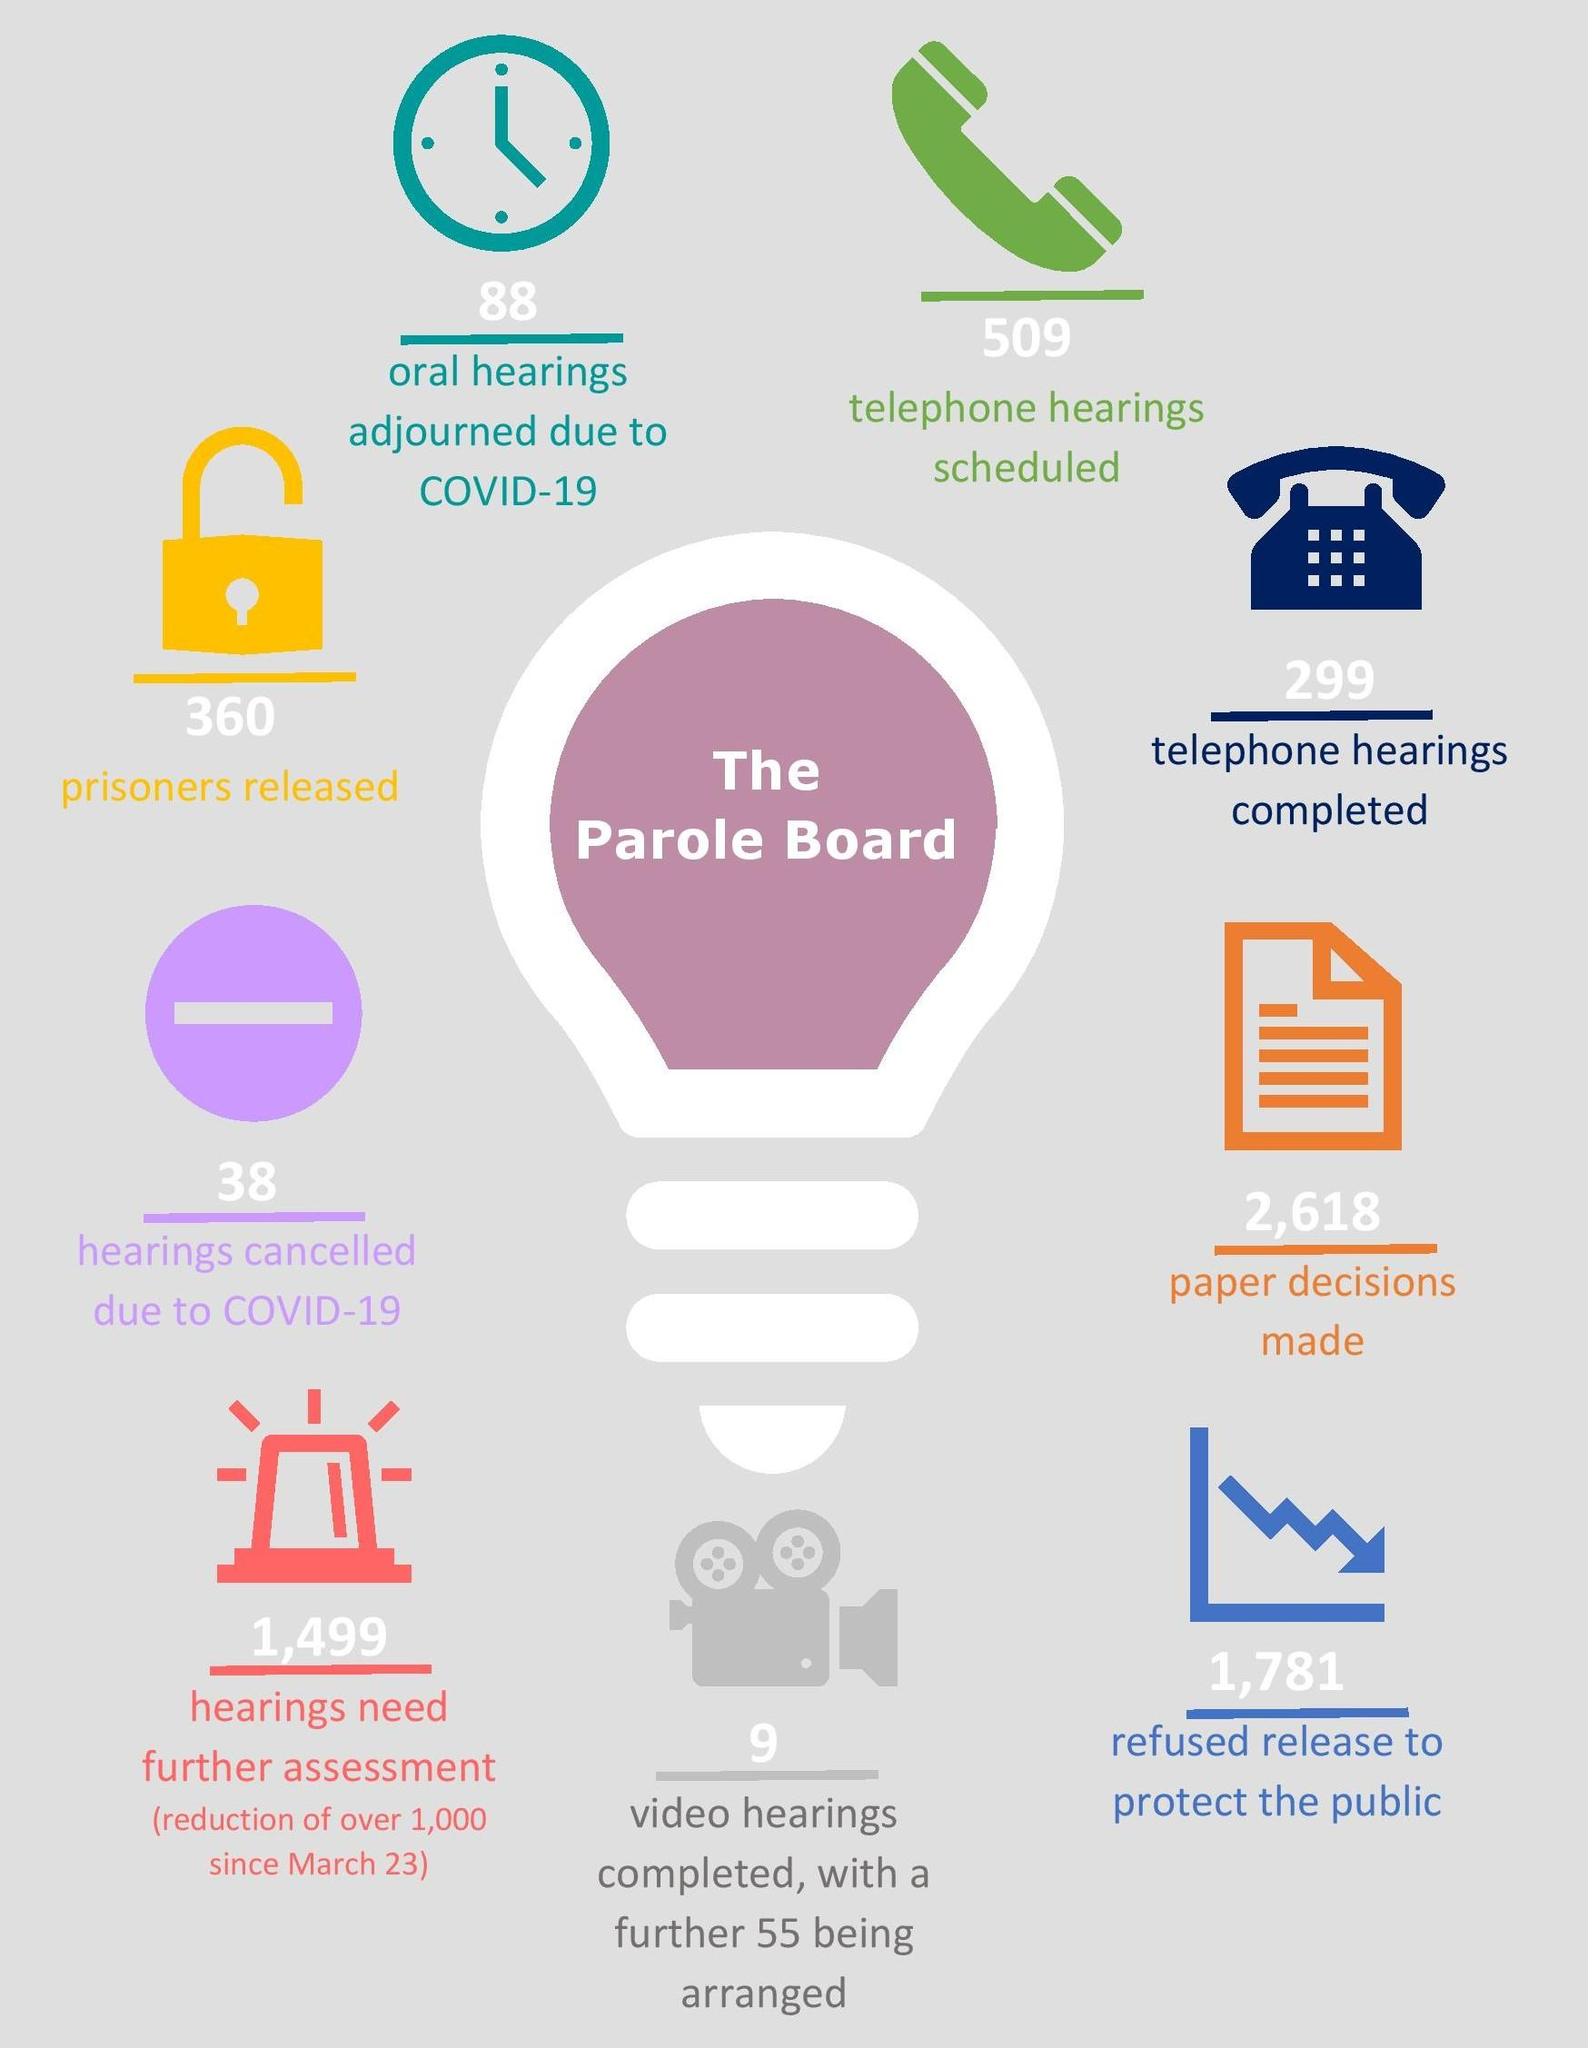List a handful of essential elements in this visual. The Parole Board is the subject of the discussion of the activities of various departments. A total of 398 prisoners have been released and 1,609 hearings have been cancelled due to COVID-19 as of September 2021. The telephone hearings scheduled and completed were 210. The color of the lock is yellow. It is necessary to conduct further assessments on 1,499 hearings. 